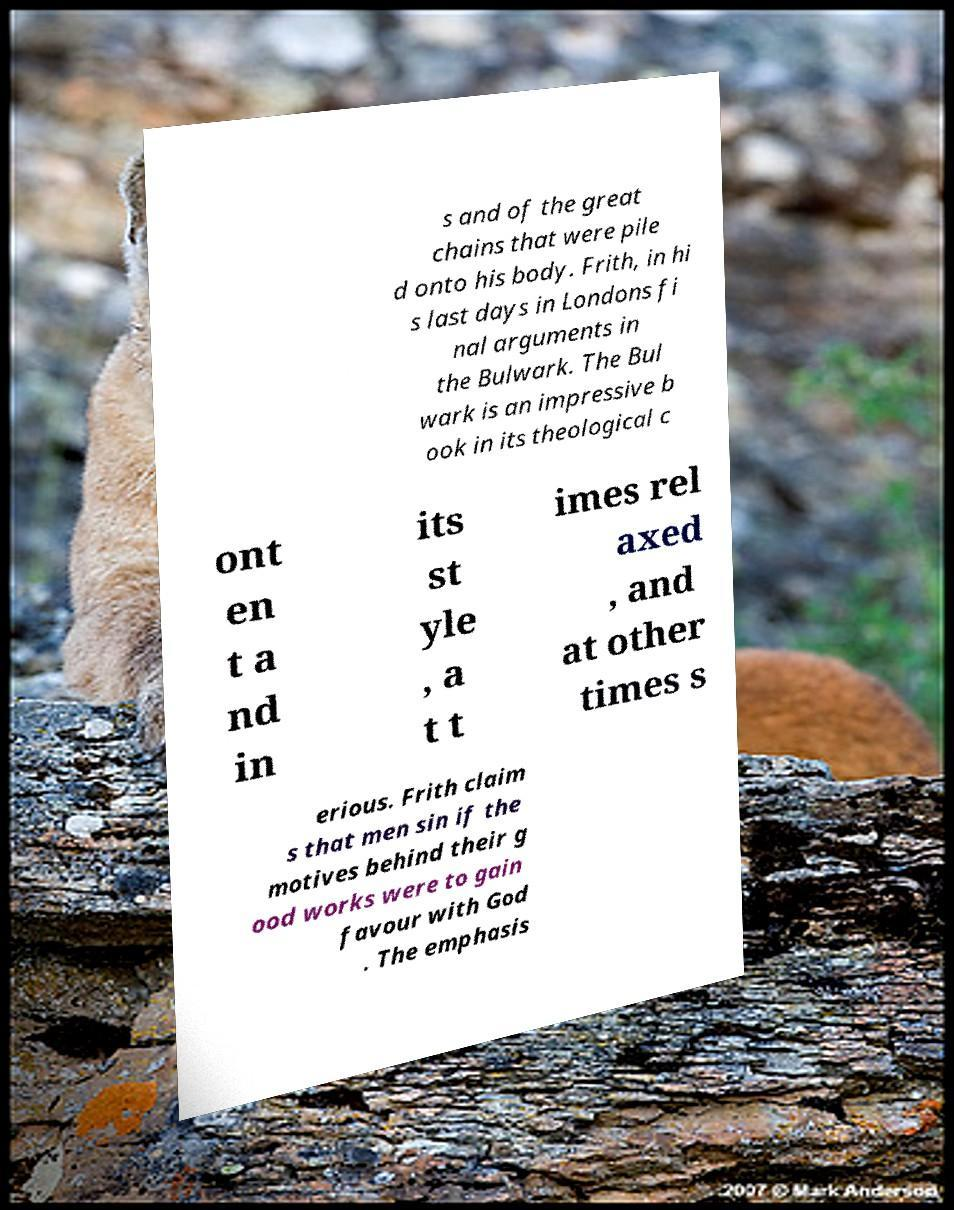Can you accurately transcribe the text from the provided image for me? s and of the great chains that were pile d onto his body. Frith, in hi s last days in Londons fi nal arguments in the Bulwark. The Bul wark is an impressive b ook in its theological c ont en t a nd in its st yle , a t t imes rel axed , and at other times s erious. Frith claim s that men sin if the motives behind their g ood works were to gain favour with God . The emphasis 